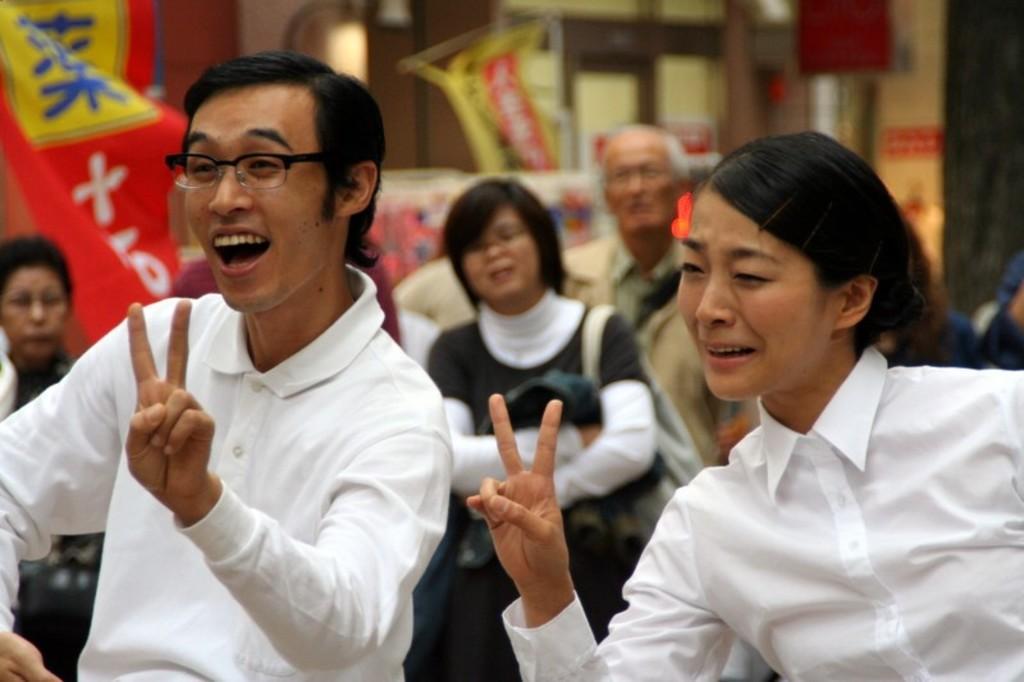Describe this image in one or two sentences. In this image, we can see a man and a lady smiling and showing their fingers. In the background, there are some people and we can see banners. 